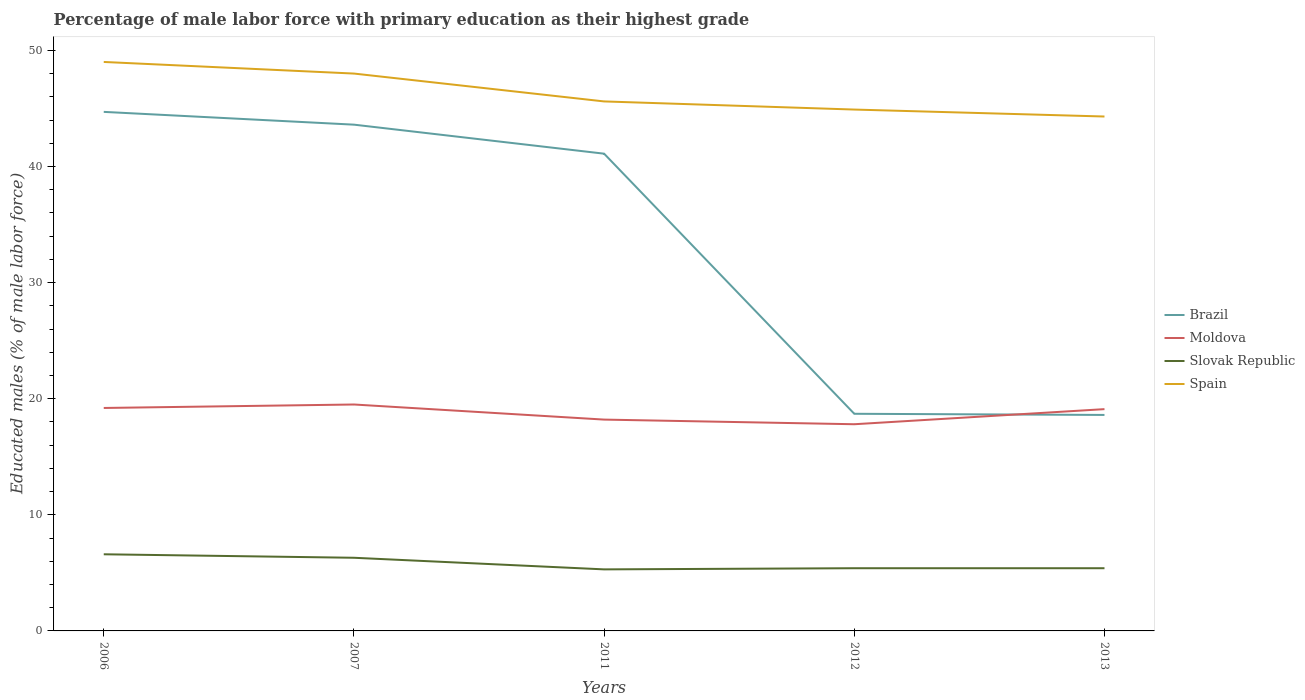Does the line corresponding to Brazil intersect with the line corresponding to Spain?
Make the answer very short. No. Is the number of lines equal to the number of legend labels?
Offer a very short reply. Yes. Across all years, what is the maximum percentage of male labor force with primary education in Moldova?
Give a very brief answer. 17.8. What is the total percentage of male labor force with primary education in Slovak Republic in the graph?
Provide a succinct answer. 1.2. What is the difference between the highest and the second highest percentage of male labor force with primary education in Spain?
Your answer should be very brief. 4.7. What is the difference between the highest and the lowest percentage of male labor force with primary education in Spain?
Your answer should be very brief. 2. How many lines are there?
Offer a very short reply. 4. What is the difference between two consecutive major ticks on the Y-axis?
Make the answer very short. 10. Does the graph contain grids?
Keep it short and to the point. No. What is the title of the graph?
Your answer should be very brief. Percentage of male labor force with primary education as their highest grade. What is the label or title of the X-axis?
Give a very brief answer. Years. What is the label or title of the Y-axis?
Offer a very short reply. Educated males (% of male labor force). What is the Educated males (% of male labor force) in Brazil in 2006?
Offer a very short reply. 44.7. What is the Educated males (% of male labor force) in Moldova in 2006?
Your answer should be very brief. 19.2. What is the Educated males (% of male labor force) in Slovak Republic in 2006?
Give a very brief answer. 6.6. What is the Educated males (% of male labor force) of Brazil in 2007?
Make the answer very short. 43.6. What is the Educated males (% of male labor force) in Moldova in 2007?
Make the answer very short. 19.5. What is the Educated males (% of male labor force) of Slovak Republic in 2007?
Your answer should be very brief. 6.3. What is the Educated males (% of male labor force) of Brazil in 2011?
Offer a terse response. 41.1. What is the Educated males (% of male labor force) in Moldova in 2011?
Offer a terse response. 18.2. What is the Educated males (% of male labor force) in Slovak Republic in 2011?
Provide a short and direct response. 5.3. What is the Educated males (% of male labor force) of Spain in 2011?
Keep it short and to the point. 45.6. What is the Educated males (% of male labor force) in Brazil in 2012?
Offer a very short reply. 18.7. What is the Educated males (% of male labor force) in Moldova in 2012?
Your response must be concise. 17.8. What is the Educated males (% of male labor force) of Slovak Republic in 2012?
Keep it short and to the point. 5.4. What is the Educated males (% of male labor force) of Spain in 2012?
Make the answer very short. 44.9. What is the Educated males (% of male labor force) in Brazil in 2013?
Make the answer very short. 18.6. What is the Educated males (% of male labor force) in Moldova in 2013?
Offer a terse response. 19.1. What is the Educated males (% of male labor force) in Slovak Republic in 2013?
Make the answer very short. 5.4. What is the Educated males (% of male labor force) of Spain in 2013?
Keep it short and to the point. 44.3. Across all years, what is the maximum Educated males (% of male labor force) in Brazil?
Keep it short and to the point. 44.7. Across all years, what is the maximum Educated males (% of male labor force) of Slovak Republic?
Your response must be concise. 6.6. Across all years, what is the minimum Educated males (% of male labor force) in Brazil?
Offer a terse response. 18.6. Across all years, what is the minimum Educated males (% of male labor force) in Moldova?
Make the answer very short. 17.8. Across all years, what is the minimum Educated males (% of male labor force) of Slovak Republic?
Provide a short and direct response. 5.3. Across all years, what is the minimum Educated males (% of male labor force) in Spain?
Provide a succinct answer. 44.3. What is the total Educated males (% of male labor force) in Brazil in the graph?
Give a very brief answer. 166.7. What is the total Educated males (% of male labor force) of Moldova in the graph?
Keep it short and to the point. 93.8. What is the total Educated males (% of male labor force) in Slovak Republic in the graph?
Offer a terse response. 29. What is the total Educated males (% of male labor force) in Spain in the graph?
Offer a terse response. 231.8. What is the difference between the Educated males (% of male labor force) in Slovak Republic in 2006 and that in 2007?
Ensure brevity in your answer.  0.3. What is the difference between the Educated males (% of male labor force) in Moldova in 2006 and that in 2011?
Ensure brevity in your answer.  1. What is the difference between the Educated males (% of male labor force) of Slovak Republic in 2006 and that in 2011?
Ensure brevity in your answer.  1.3. What is the difference between the Educated males (% of male labor force) in Spain in 2006 and that in 2011?
Your answer should be compact. 3.4. What is the difference between the Educated males (% of male labor force) of Slovak Republic in 2006 and that in 2012?
Ensure brevity in your answer.  1.2. What is the difference between the Educated males (% of male labor force) of Spain in 2006 and that in 2012?
Keep it short and to the point. 4.1. What is the difference between the Educated males (% of male labor force) in Brazil in 2006 and that in 2013?
Provide a succinct answer. 26.1. What is the difference between the Educated males (% of male labor force) of Spain in 2006 and that in 2013?
Provide a short and direct response. 4.7. What is the difference between the Educated males (% of male labor force) in Brazil in 2007 and that in 2011?
Ensure brevity in your answer.  2.5. What is the difference between the Educated males (% of male labor force) in Moldova in 2007 and that in 2011?
Provide a short and direct response. 1.3. What is the difference between the Educated males (% of male labor force) of Spain in 2007 and that in 2011?
Give a very brief answer. 2.4. What is the difference between the Educated males (% of male labor force) of Brazil in 2007 and that in 2012?
Keep it short and to the point. 24.9. What is the difference between the Educated males (% of male labor force) in Moldova in 2007 and that in 2012?
Provide a short and direct response. 1.7. What is the difference between the Educated males (% of male labor force) of Slovak Republic in 2007 and that in 2012?
Make the answer very short. 0.9. What is the difference between the Educated males (% of male labor force) in Spain in 2007 and that in 2012?
Offer a very short reply. 3.1. What is the difference between the Educated males (% of male labor force) in Brazil in 2007 and that in 2013?
Offer a very short reply. 25. What is the difference between the Educated males (% of male labor force) of Moldova in 2007 and that in 2013?
Your response must be concise. 0.4. What is the difference between the Educated males (% of male labor force) in Spain in 2007 and that in 2013?
Ensure brevity in your answer.  3.7. What is the difference between the Educated males (% of male labor force) of Brazil in 2011 and that in 2012?
Offer a very short reply. 22.4. What is the difference between the Educated males (% of male labor force) in Spain in 2011 and that in 2012?
Your answer should be compact. 0.7. What is the difference between the Educated males (% of male labor force) in Brazil in 2011 and that in 2013?
Your response must be concise. 22.5. What is the difference between the Educated males (% of male labor force) of Slovak Republic in 2011 and that in 2013?
Your answer should be very brief. -0.1. What is the difference between the Educated males (% of male labor force) of Spain in 2011 and that in 2013?
Your response must be concise. 1.3. What is the difference between the Educated males (% of male labor force) of Moldova in 2012 and that in 2013?
Make the answer very short. -1.3. What is the difference between the Educated males (% of male labor force) in Slovak Republic in 2012 and that in 2013?
Your answer should be compact. 0. What is the difference between the Educated males (% of male labor force) in Spain in 2012 and that in 2013?
Provide a succinct answer. 0.6. What is the difference between the Educated males (% of male labor force) in Brazil in 2006 and the Educated males (% of male labor force) in Moldova in 2007?
Keep it short and to the point. 25.2. What is the difference between the Educated males (% of male labor force) of Brazil in 2006 and the Educated males (% of male labor force) of Slovak Republic in 2007?
Your answer should be compact. 38.4. What is the difference between the Educated males (% of male labor force) in Brazil in 2006 and the Educated males (% of male labor force) in Spain in 2007?
Provide a succinct answer. -3.3. What is the difference between the Educated males (% of male labor force) of Moldova in 2006 and the Educated males (% of male labor force) of Spain in 2007?
Your answer should be very brief. -28.8. What is the difference between the Educated males (% of male labor force) of Slovak Republic in 2006 and the Educated males (% of male labor force) of Spain in 2007?
Your answer should be compact. -41.4. What is the difference between the Educated males (% of male labor force) in Brazil in 2006 and the Educated males (% of male labor force) in Slovak Republic in 2011?
Offer a terse response. 39.4. What is the difference between the Educated males (% of male labor force) of Moldova in 2006 and the Educated males (% of male labor force) of Slovak Republic in 2011?
Ensure brevity in your answer.  13.9. What is the difference between the Educated males (% of male labor force) in Moldova in 2006 and the Educated males (% of male labor force) in Spain in 2011?
Give a very brief answer. -26.4. What is the difference between the Educated males (% of male labor force) of Slovak Republic in 2006 and the Educated males (% of male labor force) of Spain in 2011?
Keep it short and to the point. -39. What is the difference between the Educated males (% of male labor force) in Brazil in 2006 and the Educated males (% of male labor force) in Moldova in 2012?
Keep it short and to the point. 26.9. What is the difference between the Educated males (% of male labor force) in Brazil in 2006 and the Educated males (% of male labor force) in Slovak Republic in 2012?
Your answer should be compact. 39.3. What is the difference between the Educated males (% of male labor force) of Brazil in 2006 and the Educated males (% of male labor force) of Spain in 2012?
Provide a short and direct response. -0.2. What is the difference between the Educated males (% of male labor force) of Moldova in 2006 and the Educated males (% of male labor force) of Slovak Republic in 2012?
Your response must be concise. 13.8. What is the difference between the Educated males (% of male labor force) of Moldova in 2006 and the Educated males (% of male labor force) of Spain in 2012?
Make the answer very short. -25.7. What is the difference between the Educated males (% of male labor force) in Slovak Republic in 2006 and the Educated males (% of male labor force) in Spain in 2012?
Offer a terse response. -38.3. What is the difference between the Educated males (% of male labor force) of Brazil in 2006 and the Educated males (% of male labor force) of Moldova in 2013?
Keep it short and to the point. 25.6. What is the difference between the Educated males (% of male labor force) of Brazil in 2006 and the Educated males (% of male labor force) of Slovak Republic in 2013?
Offer a terse response. 39.3. What is the difference between the Educated males (% of male labor force) of Moldova in 2006 and the Educated males (% of male labor force) of Spain in 2013?
Provide a short and direct response. -25.1. What is the difference between the Educated males (% of male labor force) in Slovak Republic in 2006 and the Educated males (% of male labor force) in Spain in 2013?
Provide a succinct answer. -37.7. What is the difference between the Educated males (% of male labor force) of Brazil in 2007 and the Educated males (% of male labor force) of Moldova in 2011?
Make the answer very short. 25.4. What is the difference between the Educated males (% of male labor force) of Brazil in 2007 and the Educated males (% of male labor force) of Slovak Republic in 2011?
Give a very brief answer. 38.3. What is the difference between the Educated males (% of male labor force) in Brazil in 2007 and the Educated males (% of male labor force) in Spain in 2011?
Offer a very short reply. -2. What is the difference between the Educated males (% of male labor force) of Moldova in 2007 and the Educated males (% of male labor force) of Spain in 2011?
Provide a succinct answer. -26.1. What is the difference between the Educated males (% of male labor force) in Slovak Republic in 2007 and the Educated males (% of male labor force) in Spain in 2011?
Keep it short and to the point. -39.3. What is the difference between the Educated males (% of male labor force) in Brazil in 2007 and the Educated males (% of male labor force) in Moldova in 2012?
Keep it short and to the point. 25.8. What is the difference between the Educated males (% of male labor force) in Brazil in 2007 and the Educated males (% of male labor force) in Slovak Republic in 2012?
Offer a terse response. 38.2. What is the difference between the Educated males (% of male labor force) in Brazil in 2007 and the Educated males (% of male labor force) in Spain in 2012?
Offer a very short reply. -1.3. What is the difference between the Educated males (% of male labor force) of Moldova in 2007 and the Educated males (% of male labor force) of Slovak Republic in 2012?
Your answer should be very brief. 14.1. What is the difference between the Educated males (% of male labor force) in Moldova in 2007 and the Educated males (% of male labor force) in Spain in 2012?
Make the answer very short. -25.4. What is the difference between the Educated males (% of male labor force) of Slovak Republic in 2007 and the Educated males (% of male labor force) of Spain in 2012?
Keep it short and to the point. -38.6. What is the difference between the Educated males (% of male labor force) of Brazil in 2007 and the Educated males (% of male labor force) of Slovak Republic in 2013?
Provide a succinct answer. 38.2. What is the difference between the Educated males (% of male labor force) of Brazil in 2007 and the Educated males (% of male labor force) of Spain in 2013?
Offer a terse response. -0.7. What is the difference between the Educated males (% of male labor force) in Moldova in 2007 and the Educated males (% of male labor force) in Spain in 2013?
Give a very brief answer. -24.8. What is the difference between the Educated males (% of male labor force) of Slovak Republic in 2007 and the Educated males (% of male labor force) of Spain in 2013?
Your answer should be very brief. -38. What is the difference between the Educated males (% of male labor force) in Brazil in 2011 and the Educated males (% of male labor force) in Moldova in 2012?
Give a very brief answer. 23.3. What is the difference between the Educated males (% of male labor force) of Brazil in 2011 and the Educated males (% of male labor force) of Slovak Republic in 2012?
Provide a short and direct response. 35.7. What is the difference between the Educated males (% of male labor force) of Brazil in 2011 and the Educated males (% of male labor force) of Spain in 2012?
Your answer should be compact. -3.8. What is the difference between the Educated males (% of male labor force) in Moldova in 2011 and the Educated males (% of male labor force) in Spain in 2012?
Your answer should be compact. -26.7. What is the difference between the Educated males (% of male labor force) in Slovak Republic in 2011 and the Educated males (% of male labor force) in Spain in 2012?
Provide a succinct answer. -39.6. What is the difference between the Educated males (% of male labor force) of Brazil in 2011 and the Educated males (% of male labor force) of Moldova in 2013?
Make the answer very short. 22. What is the difference between the Educated males (% of male labor force) of Brazil in 2011 and the Educated males (% of male labor force) of Slovak Republic in 2013?
Your answer should be compact. 35.7. What is the difference between the Educated males (% of male labor force) of Moldova in 2011 and the Educated males (% of male labor force) of Spain in 2013?
Your response must be concise. -26.1. What is the difference between the Educated males (% of male labor force) in Slovak Republic in 2011 and the Educated males (% of male labor force) in Spain in 2013?
Give a very brief answer. -39. What is the difference between the Educated males (% of male labor force) in Brazil in 2012 and the Educated males (% of male labor force) in Moldova in 2013?
Your response must be concise. -0.4. What is the difference between the Educated males (% of male labor force) of Brazil in 2012 and the Educated males (% of male labor force) of Slovak Republic in 2013?
Offer a very short reply. 13.3. What is the difference between the Educated males (% of male labor force) in Brazil in 2012 and the Educated males (% of male labor force) in Spain in 2013?
Give a very brief answer. -25.6. What is the difference between the Educated males (% of male labor force) of Moldova in 2012 and the Educated males (% of male labor force) of Slovak Republic in 2013?
Ensure brevity in your answer.  12.4. What is the difference between the Educated males (% of male labor force) in Moldova in 2012 and the Educated males (% of male labor force) in Spain in 2013?
Offer a very short reply. -26.5. What is the difference between the Educated males (% of male labor force) in Slovak Republic in 2012 and the Educated males (% of male labor force) in Spain in 2013?
Offer a terse response. -38.9. What is the average Educated males (% of male labor force) in Brazil per year?
Offer a terse response. 33.34. What is the average Educated males (% of male labor force) in Moldova per year?
Keep it short and to the point. 18.76. What is the average Educated males (% of male labor force) of Slovak Republic per year?
Provide a short and direct response. 5.8. What is the average Educated males (% of male labor force) of Spain per year?
Give a very brief answer. 46.36. In the year 2006, what is the difference between the Educated males (% of male labor force) in Brazil and Educated males (% of male labor force) in Slovak Republic?
Offer a terse response. 38.1. In the year 2006, what is the difference between the Educated males (% of male labor force) in Brazil and Educated males (% of male labor force) in Spain?
Give a very brief answer. -4.3. In the year 2006, what is the difference between the Educated males (% of male labor force) of Moldova and Educated males (% of male labor force) of Slovak Republic?
Your answer should be compact. 12.6. In the year 2006, what is the difference between the Educated males (% of male labor force) of Moldova and Educated males (% of male labor force) of Spain?
Provide a short and direct response. -29.8. In the year 2006, what is the difference between the Educated males (% of male labor force) of Slovak Republic and Educated males (% of male labor force) of Spain?
Ensure brevity in your answer.  -42.4. In the year 2007, what is the difference between the Educated males (% of male labor force) in Brazil and Educated males (% of male labor force) in Moldova?
Offer a terse response. 24.1. In the year 2007, what is the difference between the Educated males (% of male labor force) in Brazil and Educated males (% of male labor force) in Slovak Republic?
Provide a succinct answer. 37.3. In the year 2007, what is the difference between the Educated males (% of male labor force) in Moldova and Educated males (% of male labor force) in Slovak Republic?
Provide a succinct answer. 13.2. In the year 2007, what is the difference between the Educated males (% of male labor force) in Moldova and Educated males (% of male labor force) in Spain?
Ensure brevity in your answer.  -28.5. In the year 2007, what is the difference between the Educated males (% of male labor force) in Slovak Republic and Educated males (% of male labor force) in Spain?
Your answer should be compact. -41.7. In the year 2011, what is the difference between the Educated males (% of male labor force) in Brazil and Educated males (% of male labor force) in Moldova?
Your answer should be compact. 22.9. In the year 2011, what is the difference between the Educated males (% of male labor force) in Brazil and Educated males (% of male labor force) in Slovak Republic?
Your answer should be very brief. 35.8. In the year 2011, what is the difference between the Educated males (% of male labor force) of Brazil and Educated males (% of male labor force) of Spain?
Your answer should be compact. -4.5. In the year 2011, what is the difference between the Educated males (% of male labor force) in Moldova and Educated males (% of male labor force) in Spain?
Ensure brevity in your answer.  -27.4. In the year 2011, what is the difference between the Educated males (% of male labor force) of Slovak Republic and Educated males (% of male labor force) of Spain?
Offer a very short reply. -40.3. In the year 2012, what is the difference between the Educated males (% of male labor force) of Brazil and Educated males (% of male labor force) of Moldova?
Your answer should be very brief. 0.9. In the year 2012, what is the difference between the Educated males (% of male labor force) in Brazil and Educated males (% of male labor force) in Spain?
Your response must be concise. -26.2. In the year 2012, what is the difference between the Educated males (% of male labor force) in Moldova and Educated males (% of male labor force) in Spain?
Give a very brief answer. -27.1. In the year 2012, what is the difference between the Educated males (% of male labor force) of Slovak Republic and Educated males (% of male labor force) of Spain?
Keep it short and to the point. -39.5. In the year 2013, what is the difference between the Educated males (% of male labor force) in Brazil and Educated males (% of male labor force) in Slovak Republic?
Offer a very short reply. 13.2. In the year 2013, what is the difference between the Educated males (% of male labor force) of Brazil and Educated males (% of male labor force) of Spain?
Make the answer very short. -25.7. In the year 2013, what is the difference between the Educated males (% of male labor force) of Moldova and Educated males (% of male labor force) of Slovak Republic?
Offer a terse response. 13.7. In the year 2013, what is the difference between the Educated males (% of male labor force) of Moldova and Educated males (% of male labor force) of Spain?
Your response must be concise. -25.2. In the year 2013, what is the difference between the Educated males (% of male labor force) of Slovak Republic and Educated males (% of male labor force) of Spain?
Keep it short and to the point. -38.9. What is the ratio of the Educated males (% of male labor force) in Brazil in 2006 to that in 2007?
Give a very brief answer. 1.03. What is the ratio of the Educated males (% of male labor force) in Moldova in 2006 to that in 2007?
Give a very brief answer. 0.98. What is the ratio of the Educated males (% of male labor force) of Slovak Republic in 2006 to that in 2007?
Your answer should be very brief. 1.05. What is the ratio of the Educated males (% of male labor force) in Spain in 2006 to that in 2007?
Your response must be concise. 1.02. What is the ratio of the Educated males (% of male labor force) of Brazil in 2006 to that in 2011?
Offer a terse response. 1.09. What is the ratio of the Educated males (% of male labor force) in Moldova in 2006 to that in 2011?
Give a very brief answer. 1.05. What is the ratio of the Educated males (% of male labor force) in Slovak Republic in 2006 to that in 2011?
Ensure brevity in your answer.  1.25. What is the ratio of the Educated males (% of male labor force) of Spain in 2006 to that in 2011?
Give a very brief answer. 1.07. What is the ratio of the Educated males (% of male labor force) in Brazil in 2006 to that in 2012?
Provide a succinct answer. 2.39. What is the ratio of the Educated males (% of male labor force) of Moldova in 2006 to that in 2012?
Provide a succinct answer. 1.08. What is the ratio of the Educated males (% of male labor force) in Slovak Republic in 2006 to that in 2012?
Provide a short and direct response. 1.22. What is the ratio of the Educated males (% of male labor force) in Spain in 2006 to that in 2012?
Make the answer very short. 1.09. What is the ratio of the Educated males (% of male labor force) of Brazil in 2006 to that in 2013?
Your response must be concise. 2.4. What is the ratio of the Educated males (% of male labor force) in Slovak Republic in 2006 to that in 2013?
Provide a short and direct response. 1.22. What is the ratio of the Educated males (% of male labor force) in Spain in 2006 to that in 2013?
Make the answer very short. 1.11. What is the ratio of the Educated males (% of male labor force) of Brazil in 2007 to that in 2011?
Make the answer very short. 1.06. What is the ratio of the Educated males (% of male labor force) in Moldova in 2007 to that in 2011?
Your answer should be compact. 1.07. What is the ratio of the Educated males (% of male labor force) of Slovak Republic in 2007 to that in 2011?
Provide a succinct answer. 1.19. What is the ratio of the Educated males (% of male labor force) in Spain in 2007 to that in 2011?
Offer a very short reply. 1.05. What is the ratio of the Educated males (% of male labor force) of Brazil in 2007 to that in 2012?
Keep it short and to the point. 2.33. What is the ratio of the Educated males (% of male labor force) in Moldova in 2007 to that in 2012?
Make the answer very short. 1.1. What is the ratio of the Educated males (% of male labor force) of Spain in 2007 to that in 2012?
Ensure brevity in your answer.  1.07. What is the ratio of the Educated males (% of male labor force) of Brazil in 2007 to that in 2013?
Your answer should be very brief. 2.34. What is the ratio of the Educated males (% of male labor force) in Moldova in 2007 to that in 2013?
Provide a short and direct response. 1.02. What is the ratio of the Educated males (% of male labor force) in Slovak Republic in 2007 to that in 2013?
Offer a very short reply. 1.17. What is the ratio of the Educated males (% of male labor force) of Spain in 2007 to that in 2013?
Provide a short and direct response. 1.08. What is the ratio of the Educated males (% of male labor force) in Brazil in 2011 to that in 2012?
Offer a very short reply. 2.2. What is the ratio of the Educated males (% of male labor force) of Moldova in 2011 to that in 2012?
Your answer should be very brief. 1.02. What is the ratio of the Educated males (% of male labor force) of Slovak Republic in 2011 to that in 2012?
Offer a very short reply. 0.98. What is the ratio of the Educated males (% of male labor force) in Spain in 2011 to that in 2012?
Your answer should be very brief. 1.02. What is the ratio of the Educated males (% of male labor force) of Brazil in 2011 to that in 2013?
Ensure brevity in your answer.  2.21. What is the ratio of the Educated males (% of male labor force) in Moldova in 2011 to that in 2013?
Give a very brief answer. 0.95. What is the ratio of the Educated males (% of male labor force) in Slovak Republic in 2011 to that in 2013?
Give a very brief answer. 0.98. What is the ratio of the Educated males (% of male labor force) in Spain in 2011 to that in 2013?
Provide a succinct answer. 1.03. What is the ratio of the Educated males (% of male labor force) in Brazil in 2012 to that in 2013?
Keep it short and to the point. 1.01. What is the ratio of the Educated males (% of male labor force) of Moldova in 2012 to that in 2013?
Offer a very short reply. 0.93. What is the ratio of the Educated males (% of male labor force) of Spain in 2012 to that in 2013?
Provide a short and direct response. 1.01. What is the difference between the highest and the second highest Educated males (% of male labor force) of Brazil?
Your response must be concise. 1.1. What is the difference between the highest and the lowest Educated males (% of male labor force) in Brazil?
Offer a very short reply. 26.1. What is the difference between the highest and the lowest Educated males (% of male labor force) of Moldova?
Ensure brevity in your answer.  1.7. 